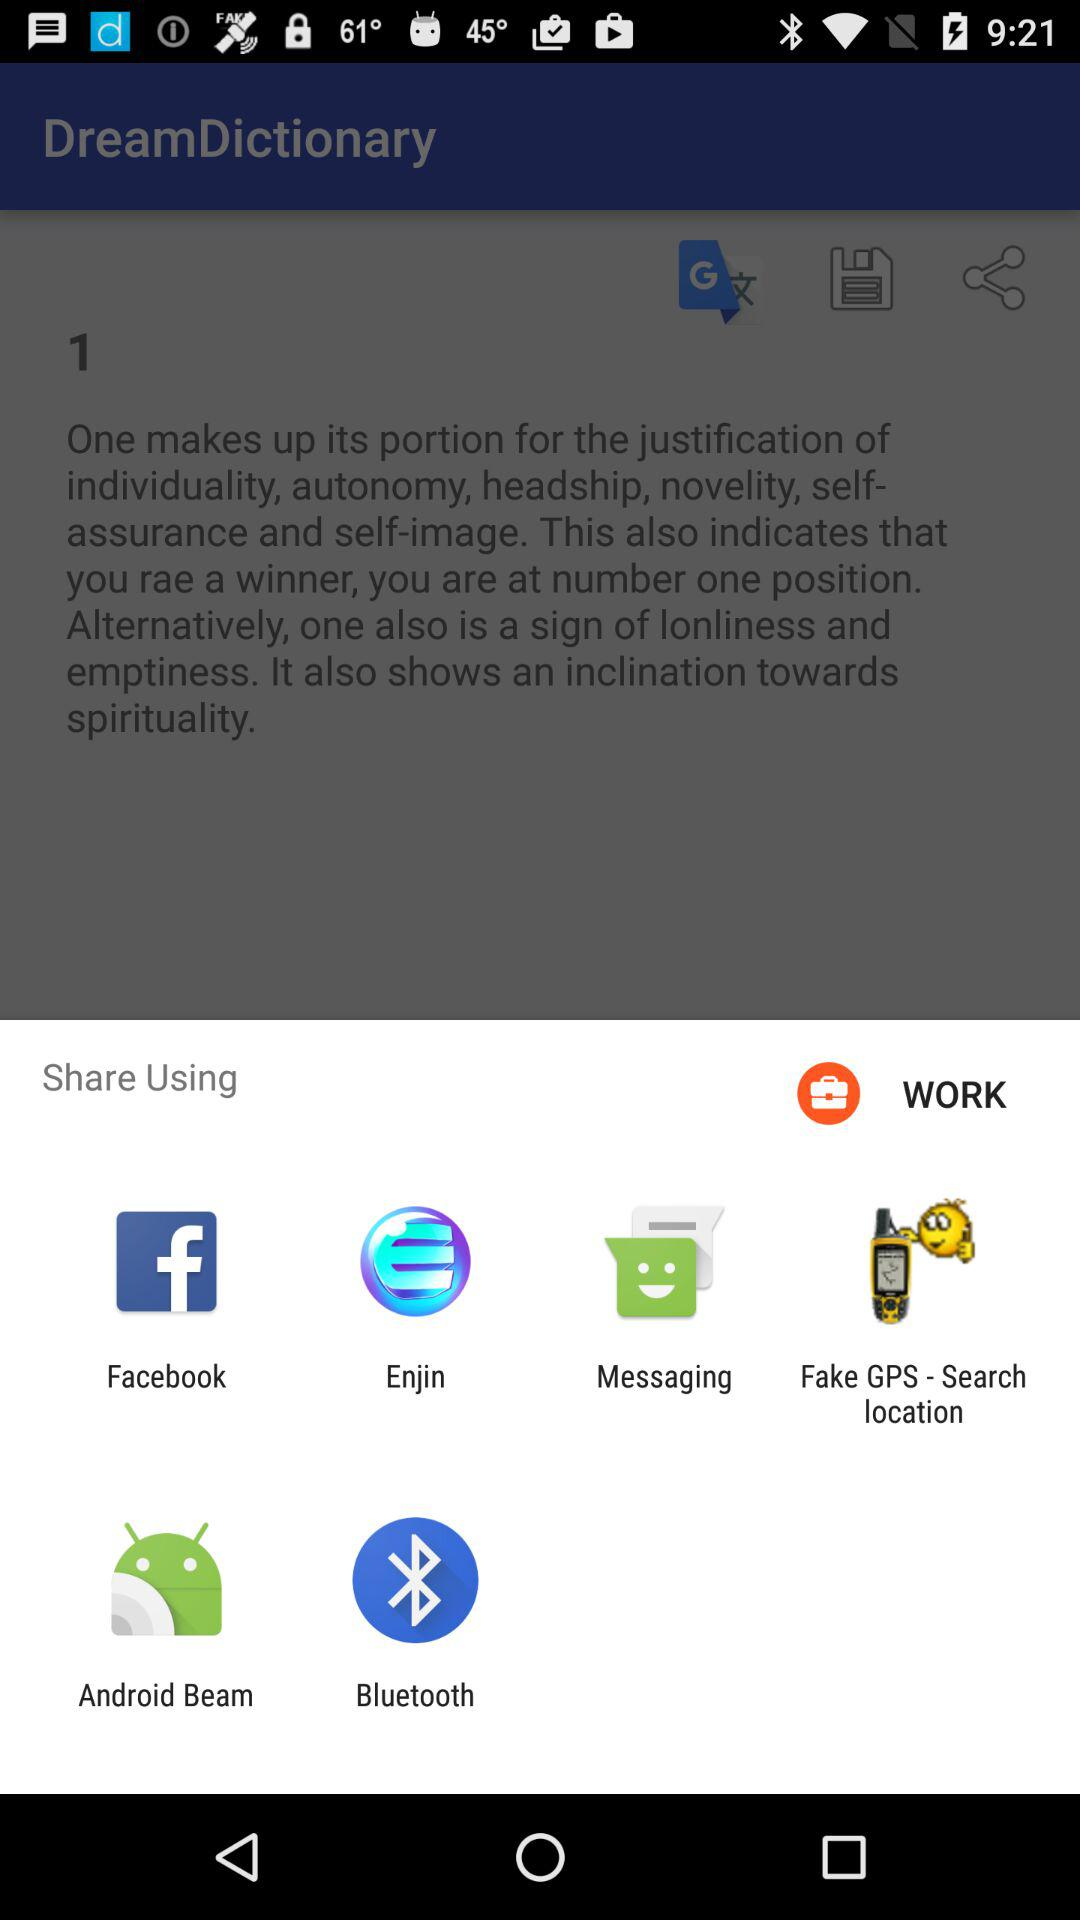Which application can be used to share? The applications that can be used to share are "Facebook", "Enjin", "Messaging", "Fake GPS - Search location", "Android Beam" and "Bluetooth". 